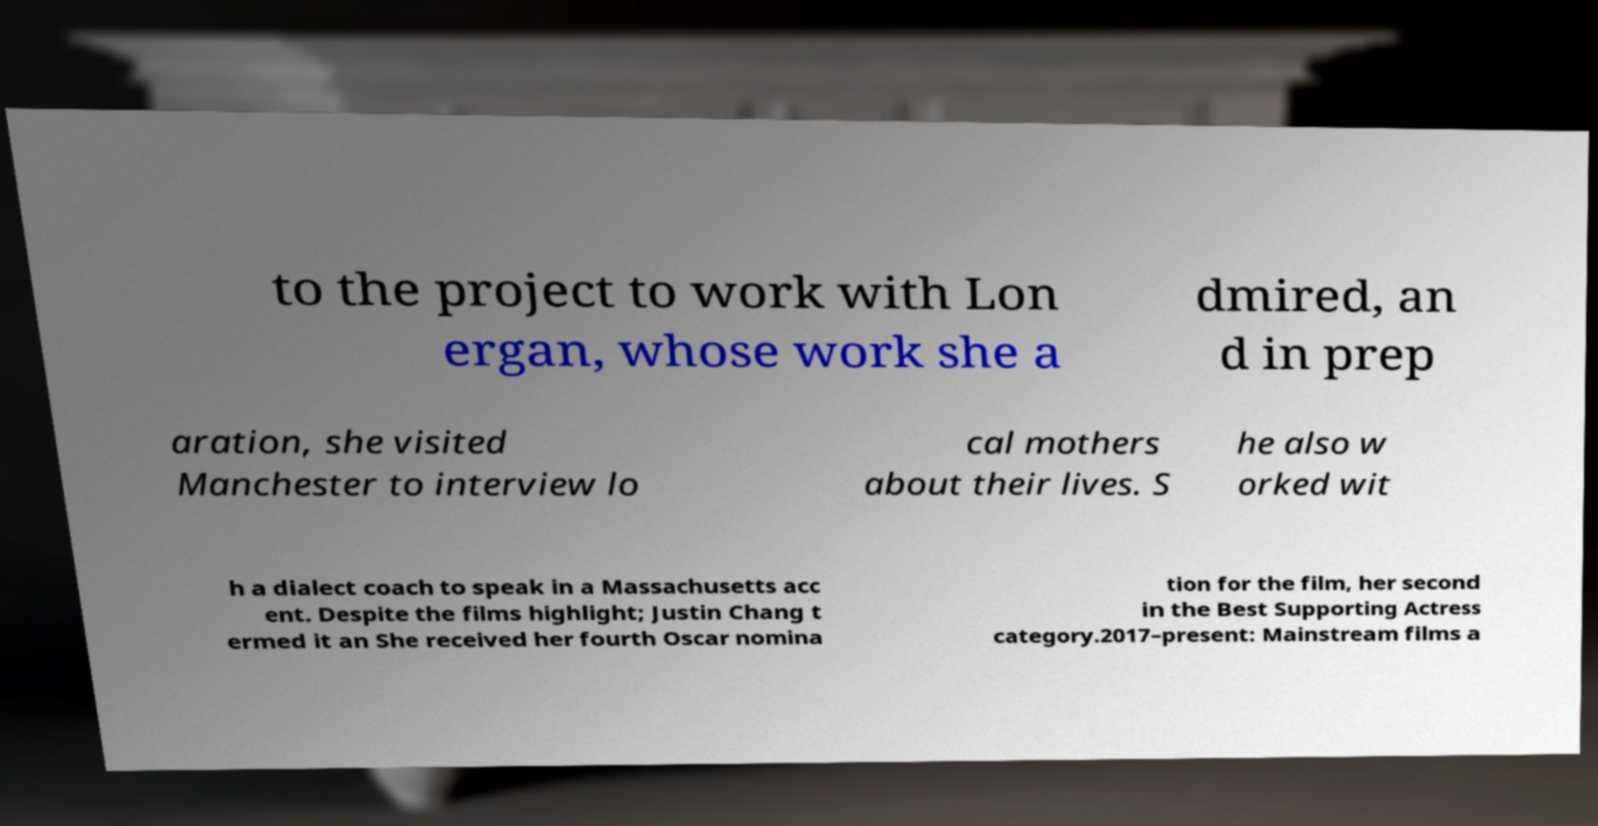Can you read and provide the text displayed in the image?This photo seems to have some interesting text. Can you extract and type it out for me? to the project to work with Lon ergan, whose work she a dmired, an d in prep aration, she visited Manchester to interview lo cal mothers about their lives. S he also w orked wit h a dialect coach to speak in a Massachusetts acc ent. Despite the films highlight; Justin Chang t ermed it an She received her fourth Oscar nomina tion for the film, her second in the Best Supporting Actress category.2017–present: Mainstream films a 